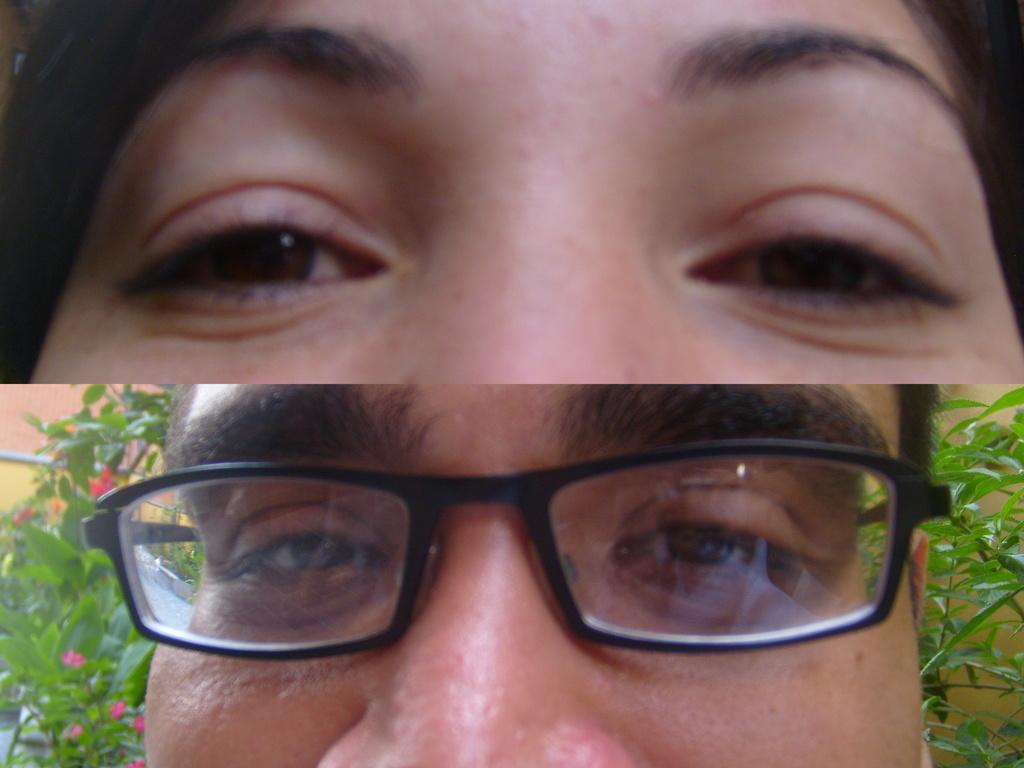Could you give a brief overview of what you see in this image? The picture is a collage of two images. At the top there is a face of a person. At the bottom there is a person with spectacles, behind him there are flowers and trees. 